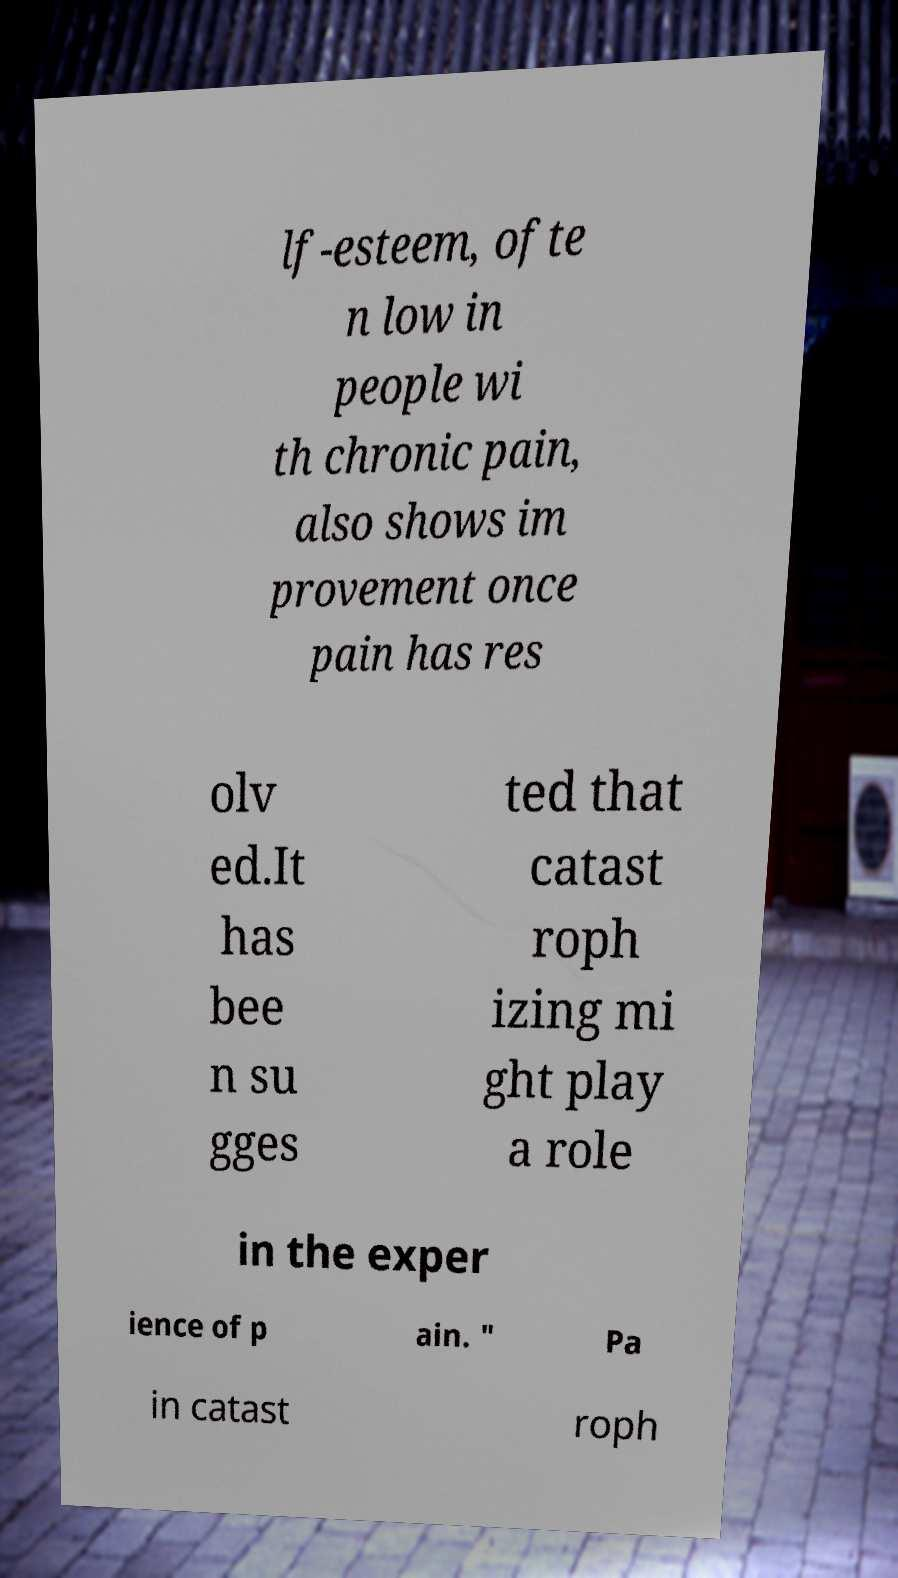Can you read and provide the text displayed in the image?This photo seems to have some interesting text. Can you extract and type it out for me? lf-esteem, ofte n low in people wi th chronic pain, also shows im provement once pain has res olv ed.It has bee n su gges ted that catast roph izing mi ght play a role in the exper ience of p ain. " Pa in catast roph 